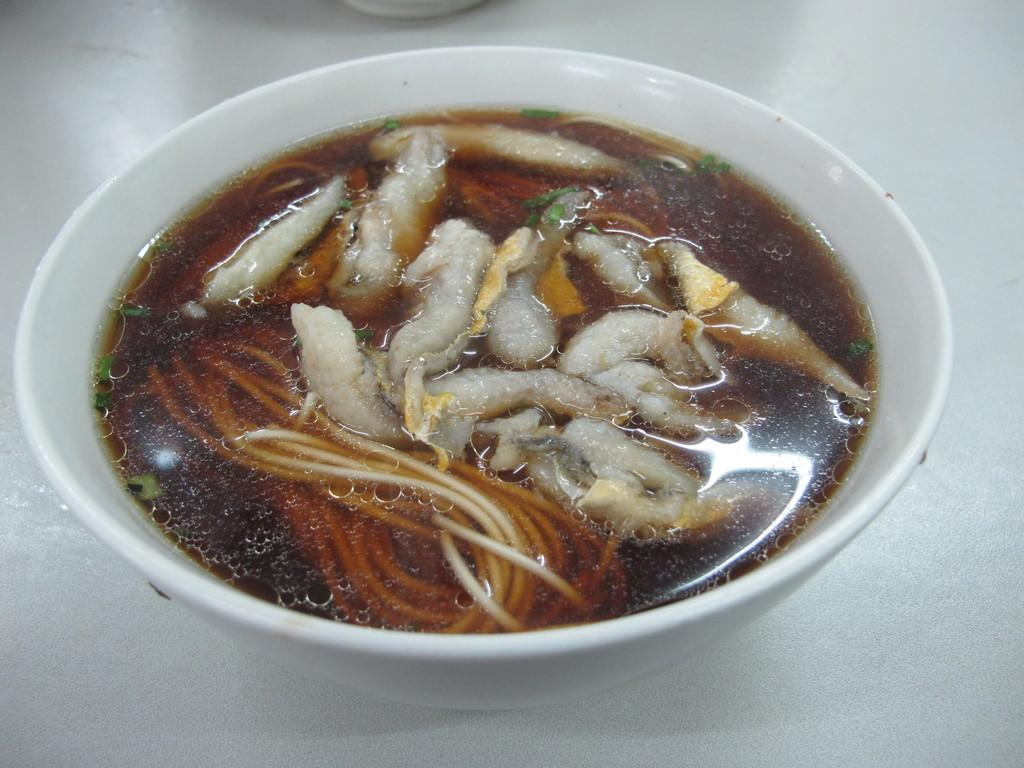What is in the bowl that is visible in the image? The bowl contains food. What can be inferred about the type of food in the bowl? The food in the bowl is not specified, but it is present. Where is the bowl located in the image? The bowl is placed on a surface. What is the shock value of the design on the bowl in the image? There is no information about the design on the bowl in the image, so it is not possible to determine its shock value. 